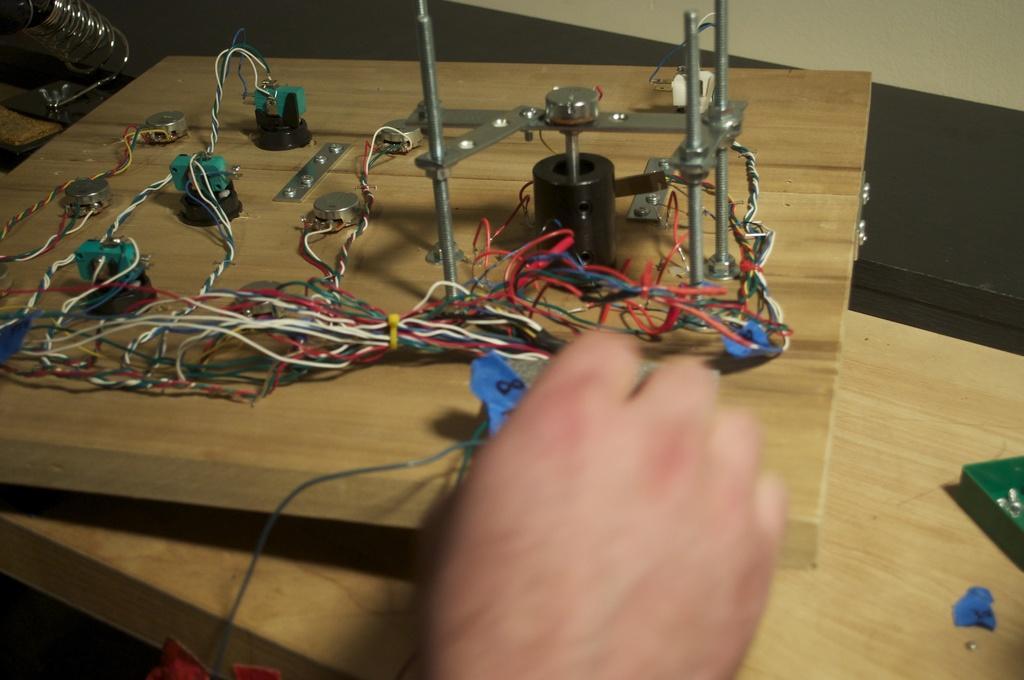In one or two sentences, can you explain what this image depicts? In this image we can see some person holding with the electrical board. 